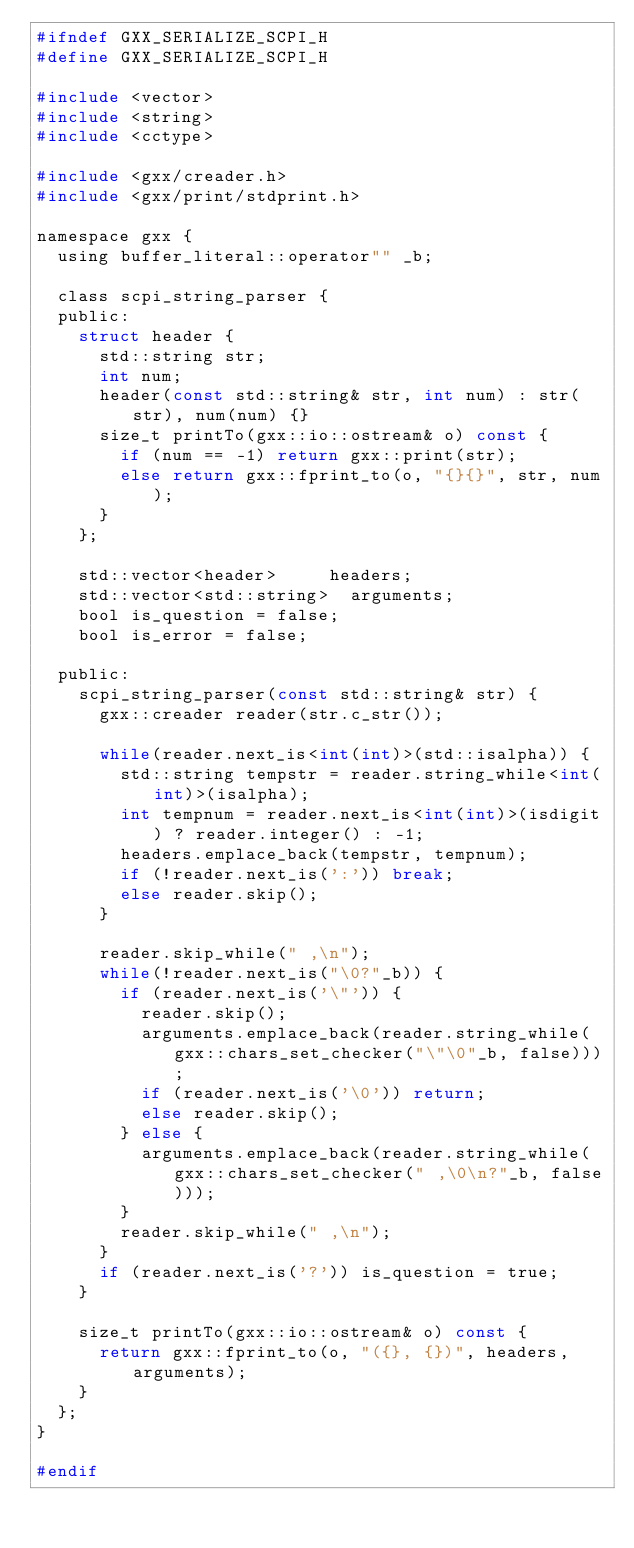<code> <loc_0><loc_0><loc_500><loc_500><_C_>#ifndef GXX_SERIALIZE_SCPI_H
#define GXX_SERIALIZE_SCPI_H

#include <vector>
#include <string>
#include <cctype>

#include <gxx/creader.h>
#include <gxx/print/stdprint.h>

namespace gxx {
	using buffer_literal::operator"" _b;

	class scpi_string_parser {
	public:
		struct header {
			std::string str;
			int num;
			header(const std::string& str, int num) : str(str), num(num) {}
			size_t printTo(gxx::io::ostream& o) const {
				if (num == -1) return gxx::print(str);
				else return gxx::fprint_to(o, "{}{}", str, num);
			}
		};

		std::vector<header> 		headers;
		std::vector<std::string> 	arguments;
		bool is_question = false;
		bool is_error = false;

	public:
		scpi_string_parser(const std::string& str) {
			gxx::creader reader(str.c_str());

			while(reader.next_is<int(int)>(std::isalpha)) {
				std::string tempstr = reader.string_while<int(int)>(isalpha);
				int tempnum = reader.next_is<int(int)>(isdigit) ? reader.integer() : -1;
				headers.emplace_back(tempstr, tempnum);
				if (!reader.next_is(':')) break;
				else reader.skip(); 
			}
	
			reader.skip_while(" ,\n");
			while(!reader.next_is("\0?"_b)) {
				if (reader.next_is('\"')) {
					reader.skip();
					arguments.emplace_back(reader.string_while(gxx::chars_set_checker("\"\0"_b, false)));
					if (reader.next_is('\0')) return;
					else reader.skip();
				} else {
					arguments.emplace_back(reader.string_while(gxx::chars_set_checker(" ,\0\n?"_b, false)));
				}
				reader.skip_while(" ,\n");
			}
			if (reader.next_is('?')) is_question = true;
		}

		size_t printTo(gxx::io::ostream& o) const {
			return gxx::fprint_to(o, "({}, {})", headers, arguments);
		}
	};
}

#endif
</code> 